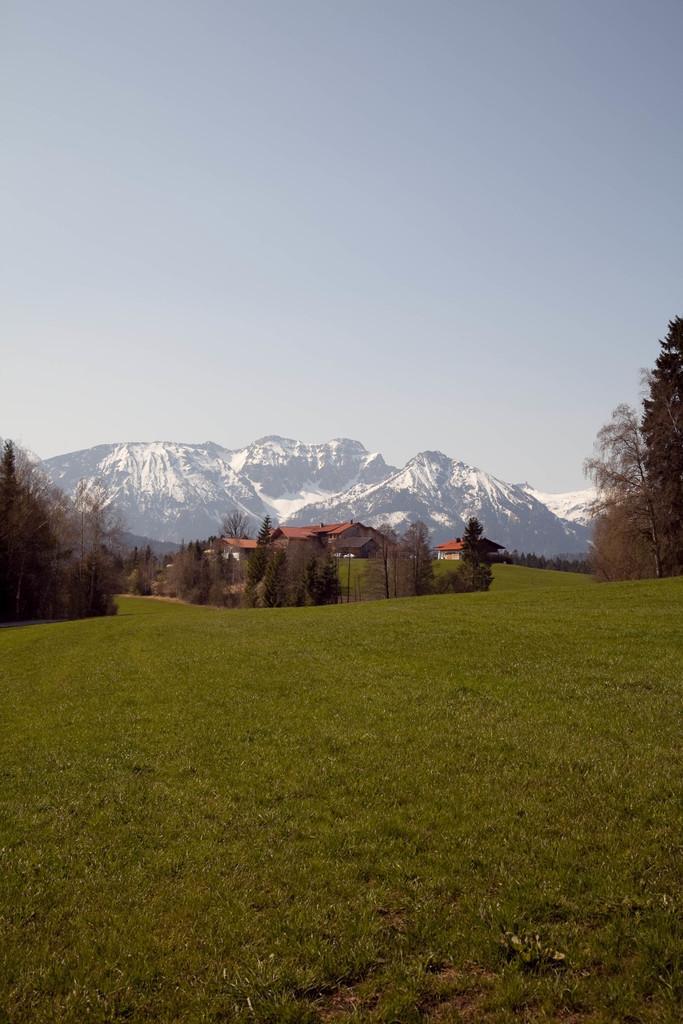How would you summarize this image in a sentence or two? This is an outside view. At the bottom of the image I can see the grass. In the background there are some houses, trees and also I can see the mountains. On the top of the image I can see the sky. 